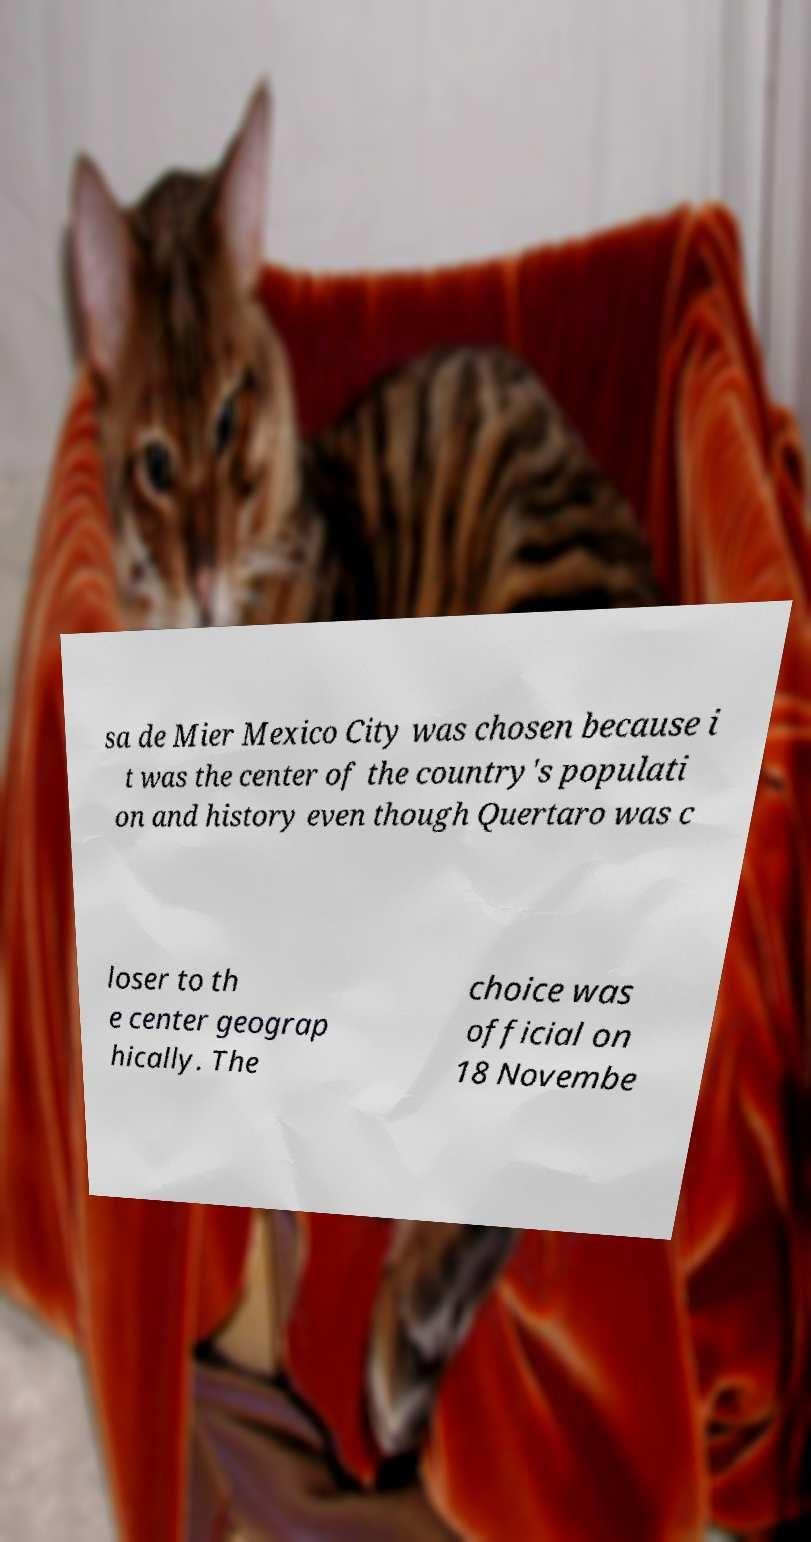Please read and relay the text visible in this image. What does it say? sa de Mier Mexico City was chosen because i t was the center of the country's populati on and history even though Quertaro was c loser to th e center geograp hically. The choice was official on 18 Novembe 